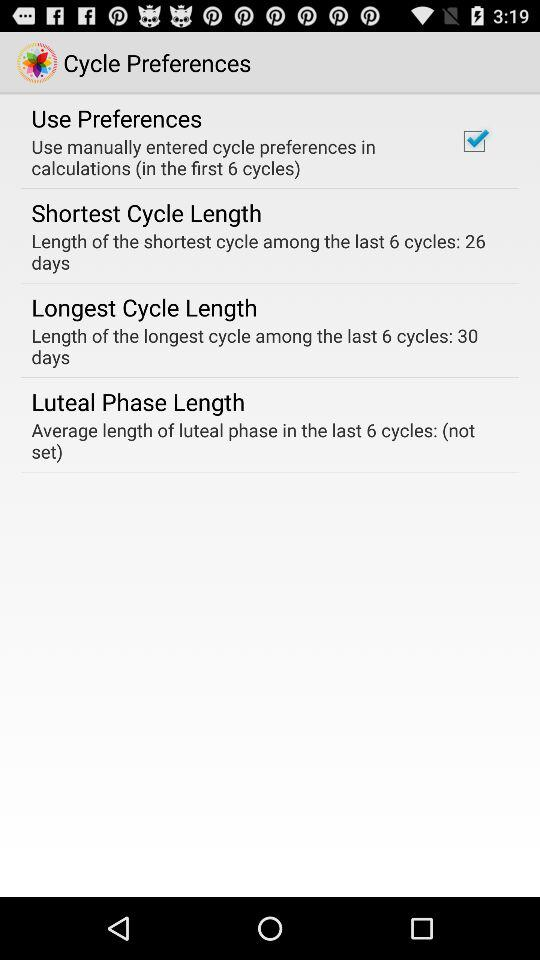How many days longer is the longest cycle than the shortest cycle?
Answer the question using a single word or phrase. 4 